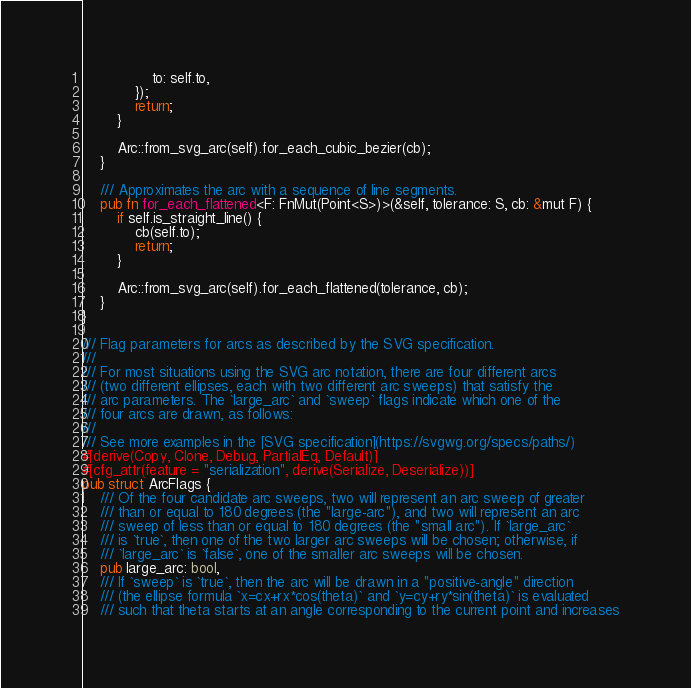Convert code to text. <code><loc_0><loc_0><loc_500><loc_500><_Rust_>                to: self.to,
            });
            return;
        }

        Arc::from_svg_arc(self).for_each_cubic_bezier(cb);
    }

    /// Approximates the arc with a sequence of line segments.
    pub fn for_each_flattened<F: FnMut(Point<S>)>(&self, tolerance: S, cb: &mut F) {
        if self.is_straight_line() {
            cb(self.to);
            return;
        }

        Arc::from_svg_arc(self).for_each_flattened(tolerance, cb);
    }
}

/// Flag parameters for arcs as described by the SVG specification.
///
/// For most situations using the SVG arc notation, there are four different arcs
/// (two different ellipses, each with two different arc sweeps) that satisfy the
/// arc parameters. The `large_arc` and `sweep` flags indicate which one of the
/// four arcs are drawn, as follows:
///
/// See more examples in the [SVG specification](https://svgwg.org/specs/paths/)
#[derive(Copy, Clone, Debug, PartialEq, Default)]
#[cfg_attr(feature = "serialization", derive(Serialize, Deserialize))]
pub struct ArcFlags {
    /// Of the four candidate arc sweeps, two will represent an arc sweep of greater
    /// than or equal to 180 degrees (the "large-arc"), and two will represent an arc
    /// sweep of less than or equal to 180 degrees (the "small arc"). If `large_arc`
    /// is `true`, then one of the two larger arc sweeps will be chosen; otherwise, if
    /// `large_arc` is `false`, one of the smaller arc sweeps will be chosen.
    pub large_arc: bool,
    /// If `sweep` is `true`, then the arc will be drawn in a "positive-angle" direction
    /// (the ellipse formula `x=cx+rx*cos(theta)` and `y=cy+ry*sin(theta)` is evaluated
    /// such that theta starts at an angle corresponding to the current point and increases</code> 